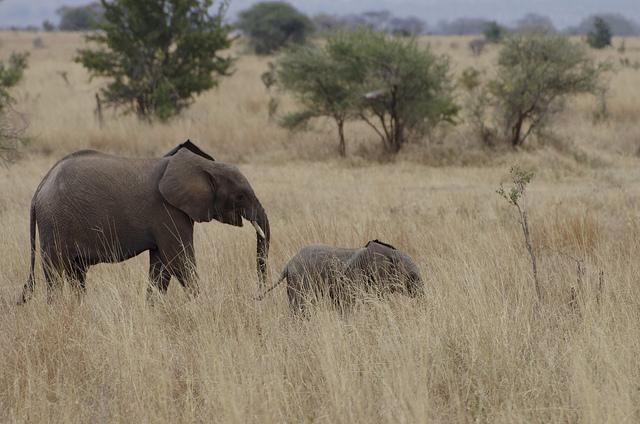How many elephants are in this photo?
Give a very brief answer. 2. How many baby elephants do you see?
Give a very brief answer. 1. How many juvenile elephants are in the picture?
Give a very brief answer. 1. How many elephants are there?
Give a very brief answer. 2. How many people are dining?
Give a very brief answer. 0. 